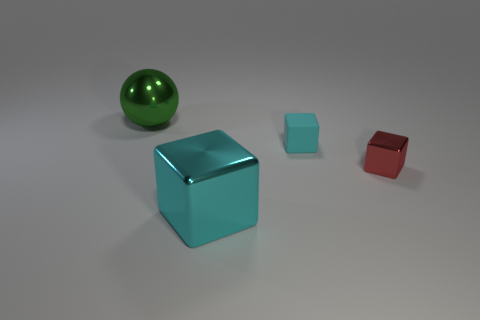Is there anything else that has the same material as the small cyan cube?
Your answer should be very brief. No. The other matte block that is the same color as the large block is what size?
Provide a short and direct response. Small. There is a big object that is in front of the large metallic thing that is behind the big shiny cube; what is its color?
Your response must be concise. Cyan. Is there another thing of the same color as the small matte thing?
Provide a succinct answer. Yes. There is a object that is the same size as the cyan matte cube; what color is it?
Offer a terse response. Red. Do the big thing that is in front of the big green sphere and the red cube have the same material?
Keep it short and to the point. Yes. There is a big object on the right side of the big shiny thing behind the tiny red metallic object; is there a large green ball that is to the left of it?
Offer a terse response. Yes. There is a big thing that is on the right side of the green metal thing; is its shape the same as the large green thing?
Make the answer very short. No. There is a large thing that is in front of the green metal object that is to the left of the tiny cyan cube; what shape is it?
Your response must be concise. Cube. How big is the cyan block that is left of the cyan cube that is right of the cyan object that is in front of the small cyan block?
Ensure brevity in your answer.  Large. 